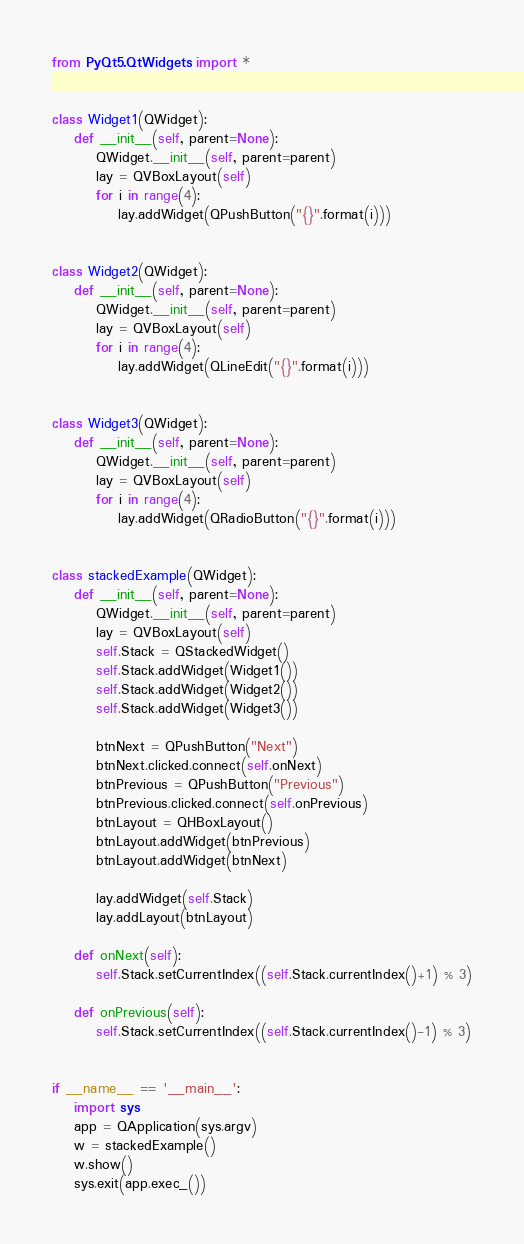<code> <loc_0><loc_0><loc_500><loc_500><_Python_>from PyQt5.QtWidgets import *


class Widget1(QWidget):
    def __init__(self, parent=None):
        QWidget.__init__(self, parent=parent)
        lay = QVBoxLayout(self)
        for i in range(4):
            lay.addWidget(QPushButton("{}".format(i)))


class Widget2(QWidget):
    def __init__(self, parent=None):
        QWidget.__init__(self, parent=parent)
        lay = QVBoxLayout(self)
        for i in range(4):
            lay.addWidget(QLineEdit("{}".format(i)))


class Widget3(QWidget):
    def __init__(self, parent=None):
        QWidget.__init__(self, parent=parent)
        lay = QVBoxLayout(self)
        for i in range(4):
            lay.addWidget(QRadioButton("{}".format(i)))


class stackedExample(QWidget):
    def __init__(self, parent=None):
        QWidget.__init__(self, parent=parent)
        lay = QVBoxLayout(self)
        self.Stack = QStackedWidget()
        self.Stack.addWidget(Widget1())
        self.Stack.addWidget(Widget2())
        self.Stack.addWidget(Widget3())

        btnNext = QPushButton("Next")
        btnNext.clicked.connect(self.onNext)
        btnPrevious = QPushButton("Previous")
        btnPrevious.clicked.connect(self.onPrevious)
        btnLayout = QHBoxLayout()
        btnLayout.addWidget(btnPrevious)
        btnLayout.addWidget(btnNext)

        lay.addWidget(self.Stack)
        lay.addLayout(btnLayout)

    def onNext(self):
        self.Stack.setCurrentIndex((self.Stack.currentIndex()+1) % 3)

    def onPrevious(self):
        self.Stack.setCurrentIndex((self.Stack.currentIndex()-1) % 3)


if __name__ == '__main__':
    import sys
    app = QApplication(sys.argv)
    w = stackedExample()
    w.show()
    sys.exit(app.exec_())


</code> 